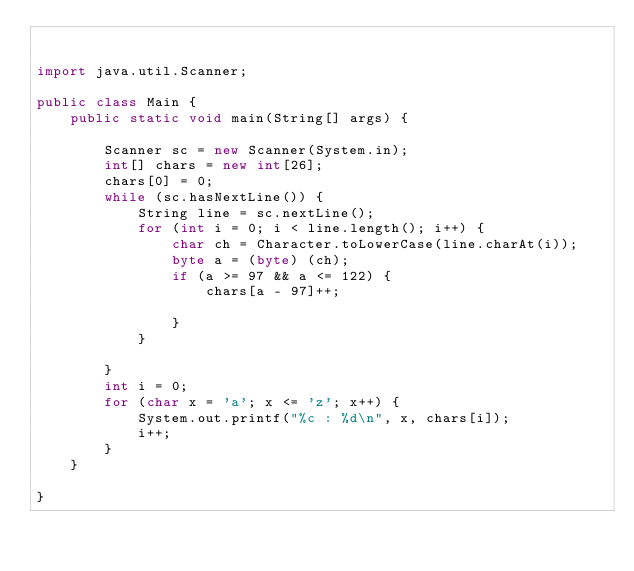<code> <loc_0><loc_0><loc_500><loc_500><_Java_>

import java.util.Scanner;

public class Main {
	public static void main(String[] args) {

		Scanner sc = new Scanner(System.in);
		int[] chars = new int[26];
		chars[0] = 0;
		while (sc.hasNextLine()) {
			String line = sc.nextLine();
			for (int i = 0; i < line.length(); i++) {
				char ch = Character.toLowerCase(line.charAt(i));
				byte a = (byte) (ch);
				if (a >= 97 && a <= 122) {
					chars[a - 97]++;

				}
			}

		}
		int i = 0;
		for (char x = 'a'; x <= 'z'; x++) {
			System.out.printf("%c : %d\n", x, chars[i]);
			i++;
		}
	}

}</code> 